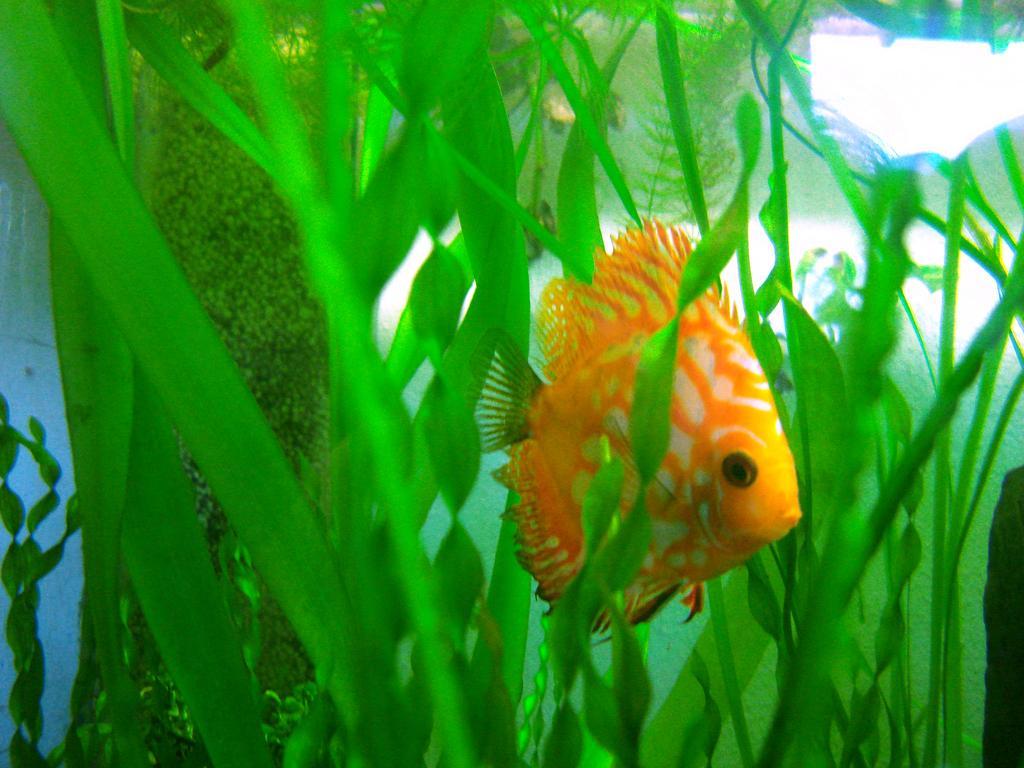Please provide a concise description of this image. In this image I can see a fish which is in orange and white color. I can see water and green color plants. 